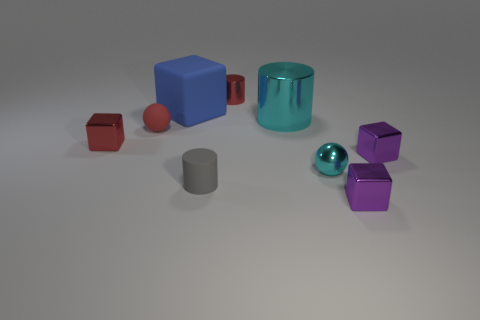Subtract 1 cubes. How many cubes are left? 3 Subtract all purple cylinders. Subtract all red spheres. How many cylinders are left? 3 Add 1 small objects. How many objects exist? 10 Subtract all balls. How many objects are left? 7 Subtract all small metal objects. Subtract all large cyan metal objects. How many objects are left? 3 Add 9 matte balls. How many matte balls are left? 10 Add 9 big gray blocks. How many big gray blocks exist? 9 Subtract 1 cyan cylinders. How many objects are left? 8 